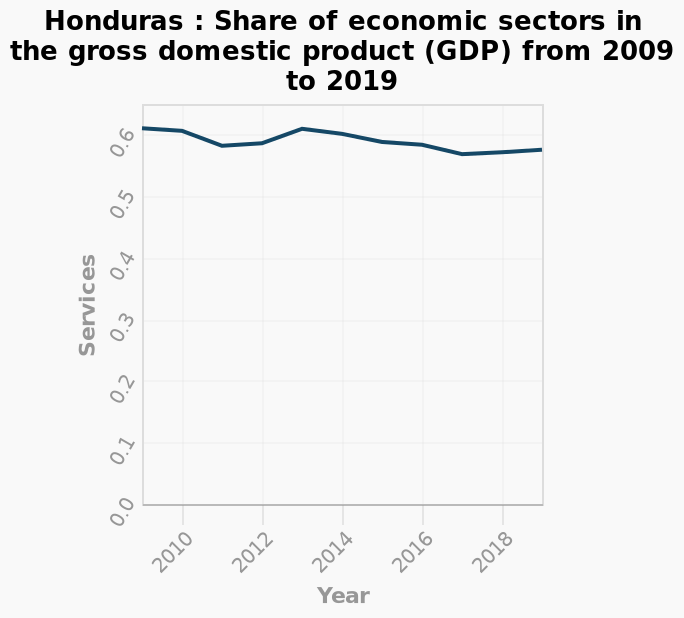<image>
What is the time period covered by the line plot? The line plot represents the time period from 2009 to 2019. 